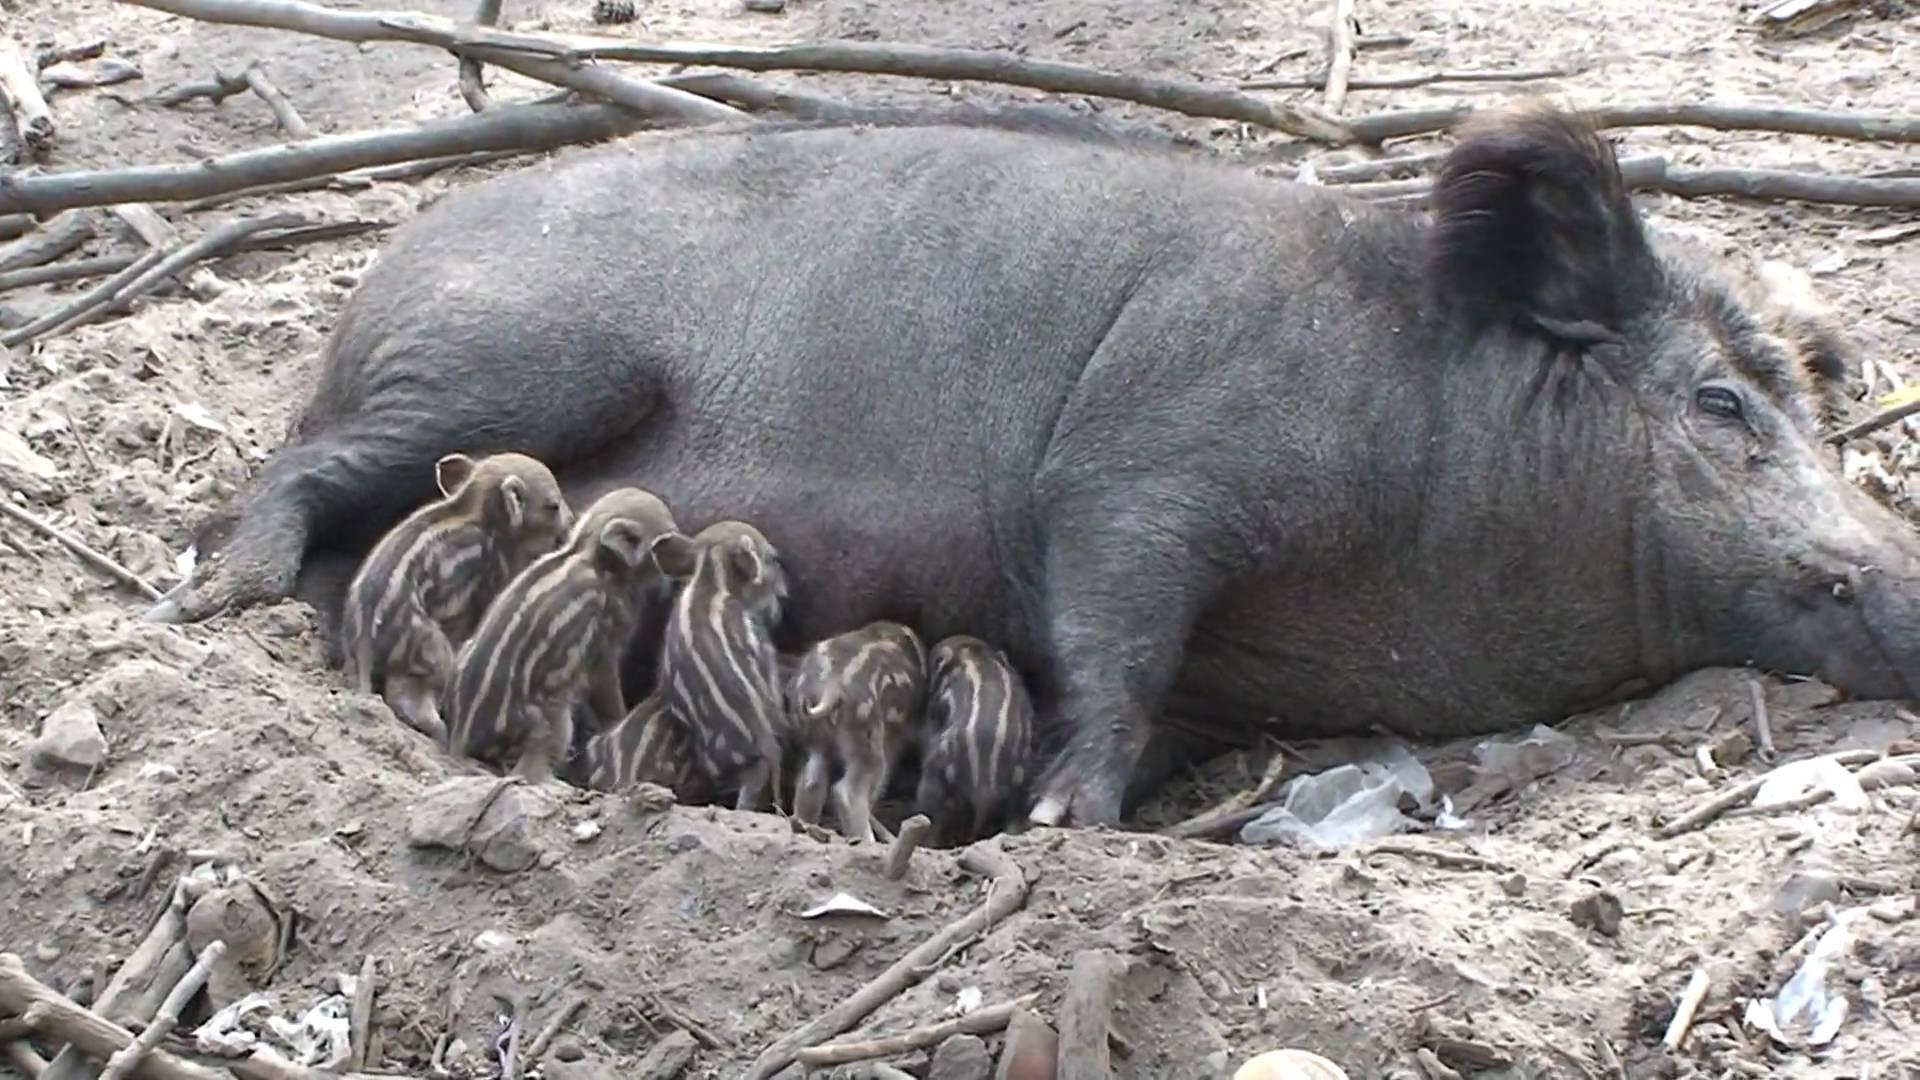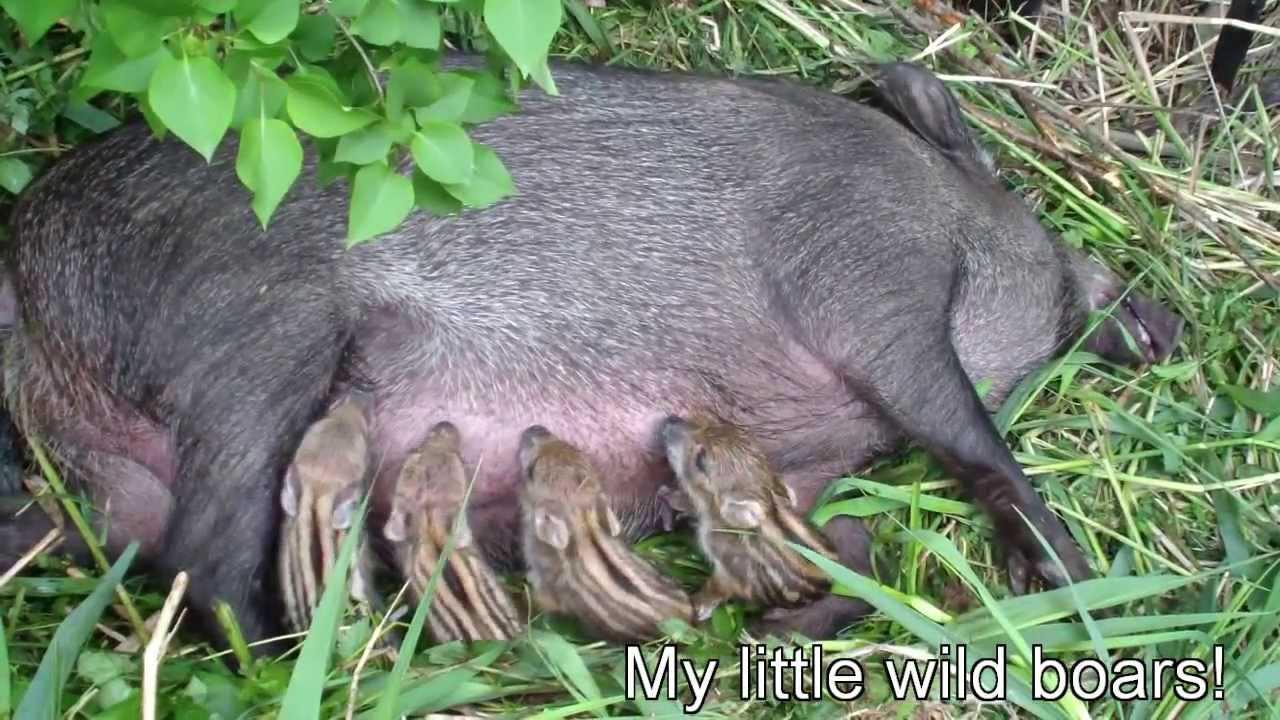The first image is the image on the left, the second image is the image on the right. Examine the images to the left and right. Is the description "Both images contain only piglets" accurate? Answer yes or no. No. 